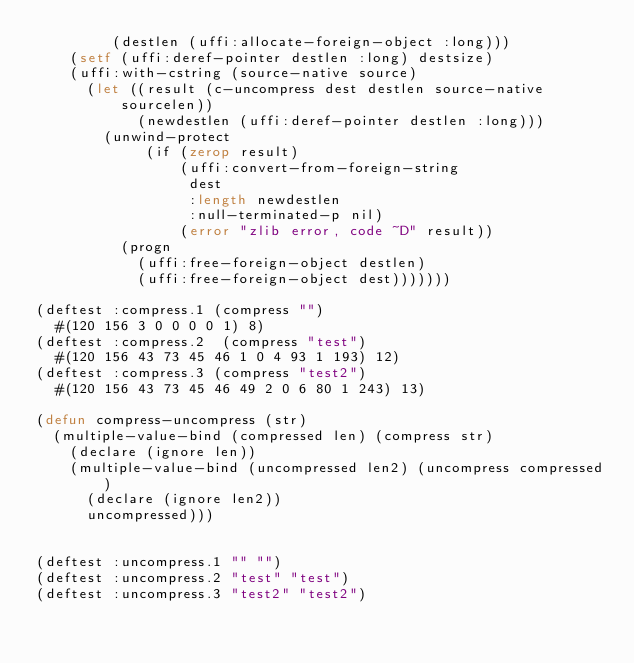Convert code to text. <code><loc_0><loc_0><loc_500><loc_500><_Lisp_>         (destlen (uffi:allocate-foreign-object :long)))
    (setf (uffi:deref-pointer destlen :long) destsize)
    (uffi:with-cstring (source-native source)
      (let ((result (c-uncompress dest destlen source-native sourcelen))
            (newdestlen (uffi:deref-pointer destlen :long)))
        (unwind-protect
             (if (zerop result)
                 (uffi:convert-from-foreign-string
                  dest
                  :length newdestlen
                  :null-terminated-p nil)
                 (error "zlib error, code ~D" result))
          (progn
            (uffi:free-foreign-object destlen)
            (uffi:free-foreign-object dest)))))))

(deftest :compress.1 (compress "")
  #(120 156 3 0 0 0 0 1) 8)
(deftest :compress.2  (compress "test")
  #(120 156 43 73 45 46 1 0 4 93 1 193) 12)
(deftest :compress.3 (compress "test2")
  #(120 156 43 73 45 46 49 2 0 6 80 1 243) 13)

(defun compress-uncompress (str)
  (multiple-value-bind (compressed len) (compress str)
    (declare (ignore len))
    (multiple-value-bind (uncompressed len2) (uncompress compressed)
      (declare (ignore len2))
      uncompressed)))


(deftest :uncompress.1 "" "")
(deftest :uncompress.2 "test" "test")
(deftest :uncompress.3 "test2" "test2")
</code> 